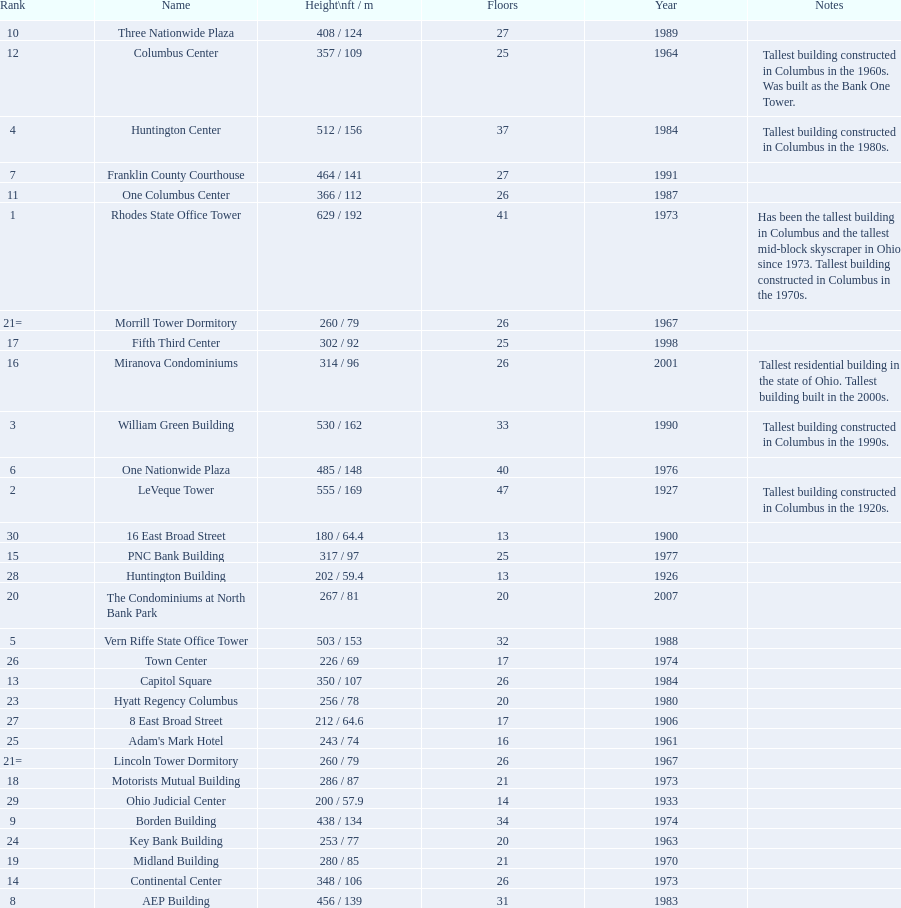What is the number of buildings under 200 ft? 1. 